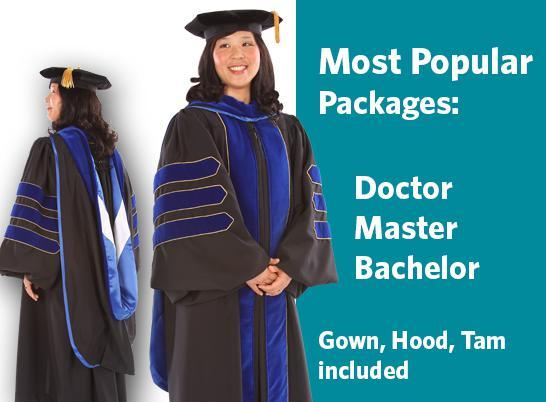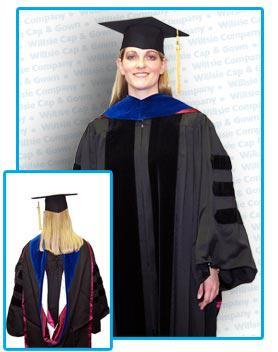The first image is the image on the left, the second image is the image on the right. Examine the images to the left and right. Is the description "There are two views of a person who is where a red sash and black graduation robe." accurate? Answer yes or no. No. The first image is the image on the left, the second image is the image on the right. For the images displayed, is the sentence "The hood of the robe in one image features a floral pattern rather than a solid color." factually correct? Answer yes or no. No. 